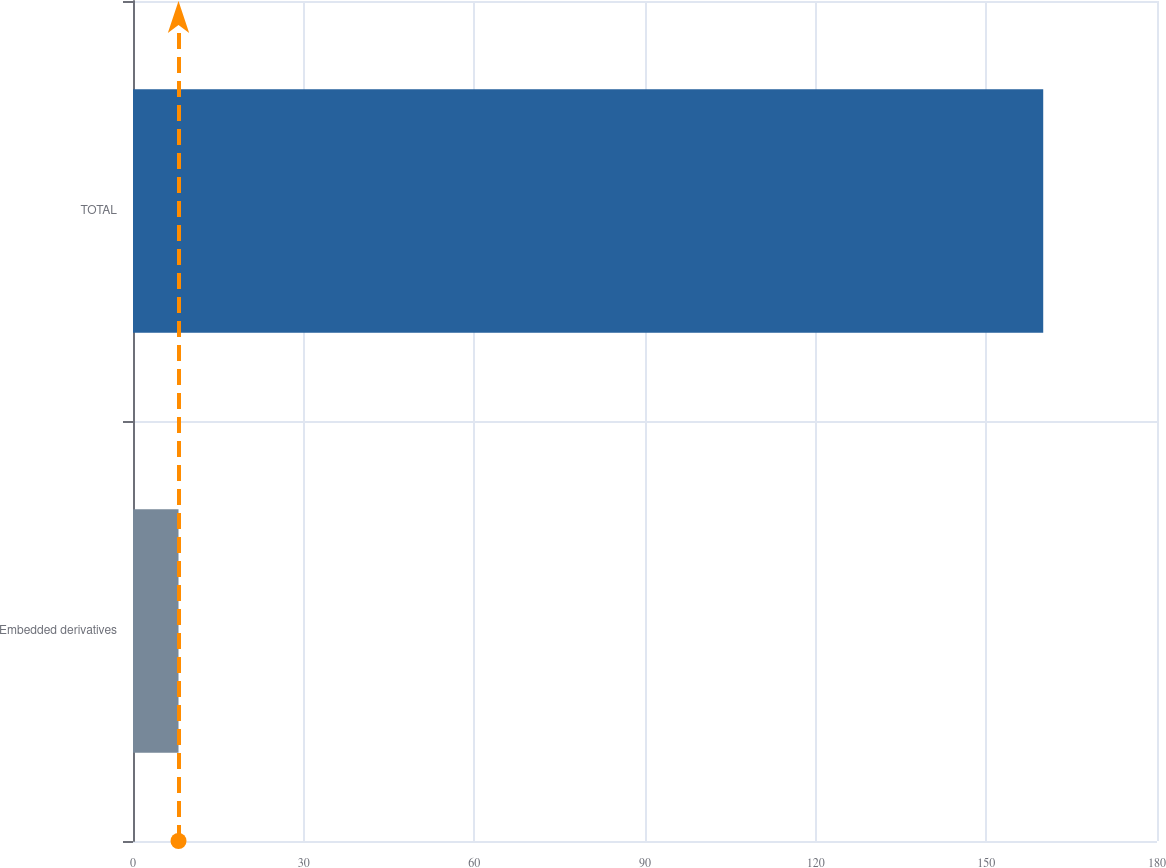Convert chart to OTSL. <chart><loc_0><loc_0><loc_500><loc_500><bar_chart><fcel>Embedded derivatives<fcel>TOTAL<nl><fcel>8<fcel>160<nl></chart> 